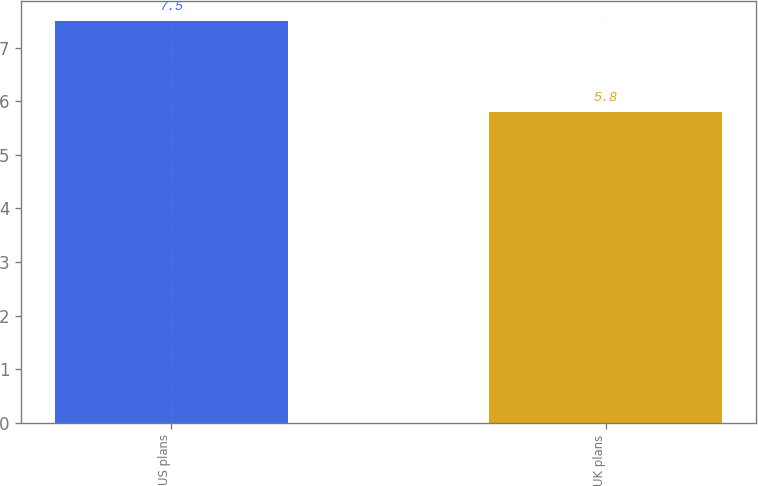Convert chart to OTSL. <chart><loc_0><loc_0><loc_500><loc_500><bar_chart><fcel>US plans<fcel>UK plans<nl><fcel>7.5<fcel>5.8<nl></chart> 